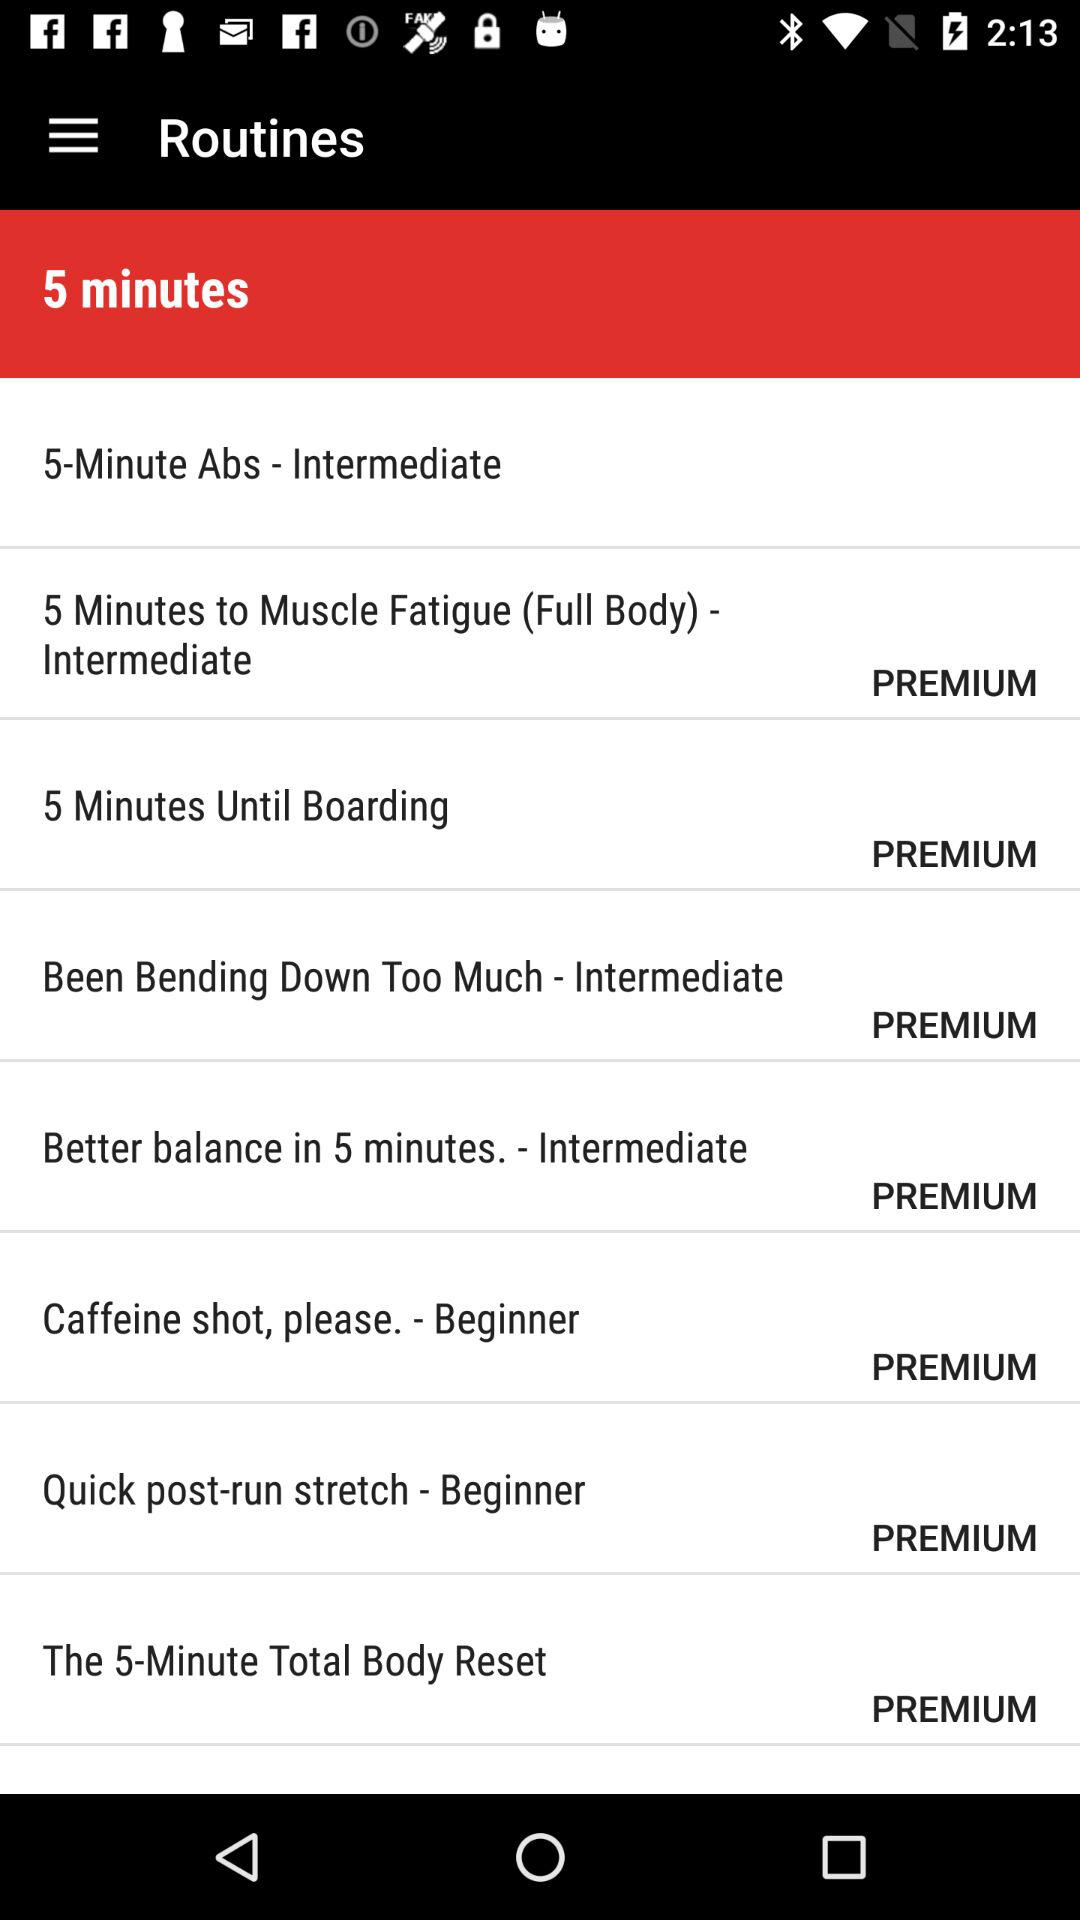Which level is mentioned for "Better balance in 5 minutes"? The mentioned level is "Intermediate". 